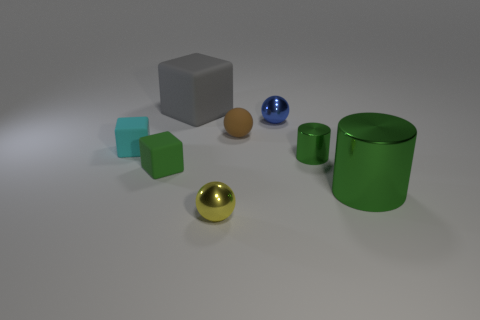What number of other things are there of the same material as the gray thing
Give a very brief answer. 3. The other metal object that is the same shape as the big metal object is what size?
Ensure brevity in your answer.  Small. Does the rubber sphere have the same color as the big cylinder?
Provide a short and direct response. No. What is the color of the small ball that is behind the yellow ball and in front of the blue metal ball?
Your answer should be very brief. Brown. What number of things are either things that are behind the cyan thing or brown metallic cubes?
Give a very brief answer. 3. What color is the other large rubber thing that is the same shape as the cyan thing?
Offer a very short reply. Gray. There is a large shiny object; is it the same shape as the matte thing behind the small blue object?
Provide a succinct answer. No. How many objects are either rubber blocks behind the green block or small cubes on the right side of the small cyan rubber block?
Your response must be concise. 3. Is the number of big cylinders in front of the tiny cyan thing less than the number of large brown balls?
Your answer should be compact. No. Is the material of the yellow ball the same as the small green object on the left side of the gray matte thing?
Your answer should be compact. No. 